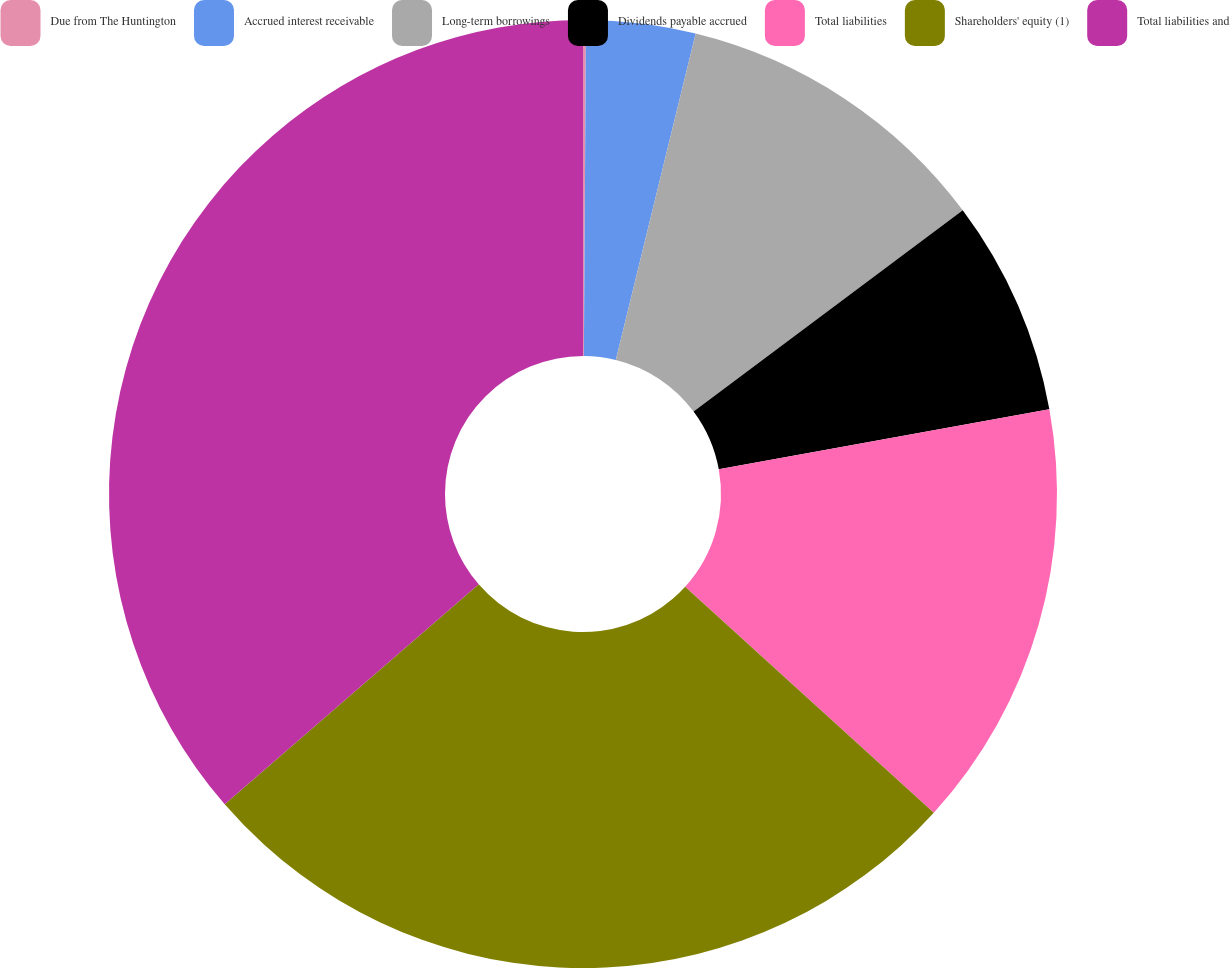Convert chart. <chart><loc_0><loc_0><loc_500><loc_500><pie_chart><fcel>Due from The Huntington<fcel>Accrued interest receivable<fcel>Long-term borrowings<fcel>Dividends payable accrued<fcel>Total liabilities<fcel>Shareholders' equity (1)<fcel>Total liabilities and<nl><fcel>0.1%<fcel>3.72%<fcel>10.97%<fcel>7.35%<fcel>14.6%<fcel>26.9%<fcel>36.36%<nl></chart> 